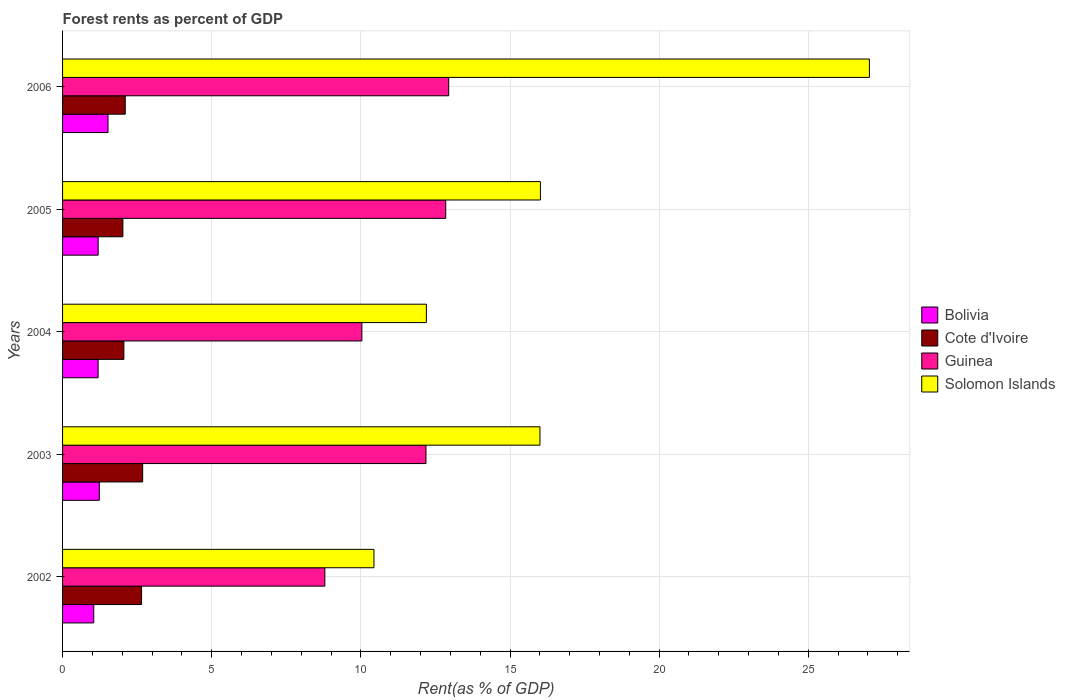How many different coloured bars are there?
Your answer should be very brief. 4. Are the number of bars per tick equal to the number of legend labels?
Ensure brevity in your answer.  Yes. Are the number of bars on each tick of the Y-axis equal?
Offer a very short reply. Yes. In how many cases, is the number of bars for a given year not equal to the number of legend labels?
Offer a terse response. 0. What is the forest rent in Bolivia in 2003?
Offer a terse response. 1.23. Across all years, what is the maximum forest rent in Bolivia?
Ensure brevity in your answer.  1.52. Across all years, what is the minimum forest rent in Cote d'Ivoire?
Your answer should be compact. 2.02. In which year was the forest rent in Solomon Islands maximum?
Give a very brief answer. 2006. What is the total forest rent in Bolivia in the graph?
Make the answer very short. 6.19. What is the difference between the forest rent in Bolivia in 2002 and that in 2005?
Ensure brevity in your answer.  -0.15. What is the difference between the forest rent in Solomon Islands in 2006 and the forest rent in Cote d'Ivoire in 2005?
Your response must be concise. 25.03. What is the average forest rent in Cote d'Ivoire per year?
Offer a very short reply. 2.3. In the year 2005, what is the difference between the forest rent in Cote d'Ivoire and forest rent in Bolivia?
Your response must be concise. 0.83. In how many years, is the forest rent in Cote d'Ivoire greater than 3 %?
Ensure brevity in your answer.  0. What is the ratio of the forest rent in Bolivia in 2003 to that in 2005?
Your response must be concise. 1.03. Is the difference between the forest rent in Cote d'Ivoire in 2002 and 2005 greater than the difference between the forest rent in Bolivia in 2002 and 2005?
Your response must be concise. Yes. What is the difference between the highest and the second highest forest rent in Bolivia?
Keep it short and to the point. 0.29. What is the difference between the highest and the lowest forest rent in Cote d'Ivoire?
Your answer should be compact. 0.66. In how many years, is the forest rent in Cote d'Ivoire greater than the average forest rent in Cote d'Ivoire taken over all years?
Your answer should be compact. 2. Is it the case that in every year, the sum of the forest rent in Cote d'Ivoire and forest rent in Guinea is greater than the sum of forest rent in Bolivia and forest rent in Solomon Islands?
Offer a very short reply. Yes. What does the 2nd bar from the top in 2005 represents?
Provide a succinct answer. Guinea. What does the 3rd bar from the bottom in 2005 represents?
Give a very brief answer. Guinea. Are all the bars in the graph horizontal?
Make the answer very short. Yes. How many years are there in the graph?
Offer a terse response. 5. What is the difference between two consecutive major ticks on the X-axis?
Keep it short and to the point. 5. Does the graph contain any zero values?
Make the answer very short. No. Where does the legend appear in the graph?
Give a very brief answer. Center right. How many legend labels are there?
Keep it short and to the point. 4. How are the legend labels stacked?
Offer a very short reply. Vertical. What is the title of the graph?
Offer a very short reply. Forest rents as percent of GDP. Does "Mauritius" appear as one of the legend labels in the graph?
Your answer should be very brief. No. What is the label or title of the X-axis?
Offer a terse response. Rent(as % of GDP). What is the Rent(as % of GDP) in Bolivia in 2002?
Your response must be concise. 1.05. What is the Rent(as % of GDP) of Cote d'Ivoire in 2002?
Offer a terse response. 2.65. What is the Rent(as % of GDP) in Guinea in 2002?
Your answer should be very brief. 8.79. What is the Rent(as % of GDP) in Solomon Islands in 2002?
Provide a succinct answer. 10.44. What is the Rent(as % of GDP) of Bolivia in 2003?
Provide a short and direct response. 1.23. What is the Rent(as % of GDP) of Cote d'Ivoire in 2003?
Your response must be concise. 2.69. What is the Rent(as % of GDP) of Guinea in 2003?
Provide a succinct answer. 12.18. What is the Rent(as % of GDP) in Solomon Islands in 2003?
Your answer should be compact. 16. What is the Rent(as % of GDP) in Bolivia in 2004?
Your answer should be very brief. 1.19. What is the Rent(as % of GDP) of Cote d'Ivoire in 2004?
Your answer should be very brief. 2.06. What is the Rent(as % of GDP) in Guinea in 2004?
Your response must be concise. 10.03. What is the Rent(as % of GDP) in Solomon Islands in 2004?
Offer a terse response. 12.2. What is the Rent(as % of GDP) of Bolivia in 2005?
Provide a short and direct response. 1.19. What is the Rent(as % of GDP) of Cote d'Ivoire in 2005?
Your response must be concise. 2.02. What is the Rent(as % of GDP) in Guinea in 2005?
Offer a terse response. 12.85. What is the Rent(as % of GDP) in Solomon Islands in 2005?
Your answer should be compact. 16.02. What is the Rent(as % of GDP) in Bolivia in 2006?
Your response must be concise. 1.52. What is the Rent(as % of GDP) in Cote d'Ivoire in 2006?
Your response must be concise. 2.1. What is the Rent(as % of GDP) in Guinea in 2006?
Offer a very short reply. 12.95. What is the Rent(as % of GDP) of Solomon Islands in 2006?
Your answer should be compact. 27.05. Across all years, what is the maximum Rent(as % of GDP) in Bolivia?
Give a very brief answer. 1.52. Across all years, what is the maximum Rent(as % of GDP) in Cote d'Ivoire?
Provide a succinct answer. 2.69. Across all years, what is the maximum Rent(as % of GDP) of Guinea?
Provide a short and direct response. 12.95. Across all years, what is the maximum Rent(as % of GDP) of Solomon Islands?
Your answer should be compact. 27.05. Across all years, what is the minimum Rent(as % of GDP) in Bolivia?
Your response must be concise. 1.05. Across all years, what is the minimum Rent(as % of GDP) in Cote d'Ivoire?
Make the answer very short. 2.02. Across all years, what is the minimum Rent(as % of GDP) in Guinea?
Provide a short and direct response. 8.79. Across all years, what is the minimum Rent(as % of GDP) in Solomon Islands?
Ensure brevity in your answer.  10.44. What is the total Rent(as % of GDP) of Bolivia in the graph?
Keep it short and to the point. 6.19. What is the total Rent(as % of GDP) in Cote d'Ivoire in the graph?
Make the answer very short. 11.51. What is the total Rent(as % of GDP) in Guinea in the graph?
Provide a short and direct response. 56.8. What is the total Rent(as % of GDP) of Solomon Islands in the graph?
Provide a succinct answer. 81.71. What is the difference between the Rent(as % of GDP) in Bolivia in 2002 and that in 2003?
Your answer should be compact. -0.19. What is the difference between the Rent(as % of GDP) of Cote d'Ivoire in 2002 and that in 2003?
Offer a very short reply. -0.04. What is the difference between the Rent(as % of GDP) of Guinea in 2002 and that in 2003?
Your response must be concise. -3.39. What is the difference between the Rent(as % of GDP) in Solomon Islands in 2002 and that in 2003?
Your response must be concise. -5.56. What is the difference between the Rent(as % of GDP) of Bolivia in 2002 and that in 2004?
Give a very brief answer. -0.15. What is the difference between the Rent(as % of GDP) of Cote d'Ivoire in 2002 and that in 2004?
Your answer should be very brief. 0.59. What is the difference between the Rent(as % of GDP) in Guinea in 2002 and that in 2004?
Offer a very short reply. -1.24. What is the difference between the Rent(as % of GDP) in Solomon Islands in 2002 and that in 2004?
Your answer should be compact. -1.76. What is the difference between the Rent(as % of GDP) of Bolivia in 2002 and that in 2005?
Your answer should be compact. -0.15. What is the difference between the Rent(as % of GDP) in Cote d'Ivoire in 2002 and that in 2005?
Provide a short and direct response. 0.63. What is the difference between the Rent(as % of GDP) of Guinea in 2002 and that in 2005?
Offer a terse response. -4.05. What is the difference between the Rent(as % of GDP) of Solomon Islands in 2002 and that in 2005?
Your answer should be compact. -5.58. What is the difference between the Rent(as % of GDP) in Bolivia in 2002 and that in 2006?
Your answer should be very brief. -0.48. What is the difference between the Rent(as % of GDP) in Cote d'Ivoire in 2002 and that in 2006?
Provide a succinct answer. 0.55. What is the difference between the Rent(as % of GDP) of Guinea in 2002 and that in 2006?
Keep it short and to the point. -4.15. What is the difference between the Rent(as % of GDP) of Solomon Islands in 2002 and that in 2006?
Your answer should be compact. -16.61. What is the difference between the Rent(as % of GDP) of Bolivia in 2003 and that in 2004?
Provide a succinct answer. 0.04. What is the difference between the Rent(as % of GDP) in Cote d'Ivoire in 2003 and that in 2004?
Your response must be concise. 0.63. What is the difference between the Rent(as % of GDP) of Guinea in 2003 and that in 2004?
Your answer should be very brief. 2.15. What is the difference between the Rent(as % of GDP) of Solomon Islands in 2003 and that in 2004?
Your answer should be very brief. 3.81. What is the difference between the Rent(as % of GDP) in Bolivia in 2003 and that in 2005?
Your response must be concise. 0.04. What is the difference between the Rent(as % of GDP) of Cote d'Ivoire in 2003 and that in 2005?
Offer a terse response. 0.66. What is the difference between the Rent(as % of GDP) in Guinea in 2003 and that in 2005?
Offer a terse response. -0.66. What is the difference between the Rent(as % of GDP) of Solomon Islands in 2003 and that in 2005?
Provide a short and direct response. -0.02. What is the difference between the Rent(as % of GDP) in Bolivia in 2003 and that in 2006?
Make the answer very short. -0.29. What is the difference between the Rent(as % of GDP) of Cote d'Ivoire in 2003 and that in 2006?
Give a very brief answer. 0.58. What is the difference between the Rent(as % of GDP) in Guinea in 2003 and that in 2006?
Give a very brief answer. -0.76. What is the difference between the Rent(as % of GDP) of Solomon Islands in 2003 and that in 2006?
Offer a terse response. -11.04. What is the difference between the Rent(as % of GDP) in Bolivia in 2004 and that in 2005?
Provide a short and direct response. -0. What is the difference between the Rent(as % of GDP) in Cote d'Ivoire in 2004 and that in 2005?
Offer a terse response. 0.03. What is the difference between the Rent(as % of GDP) in Guinea in 2004 and that in 2005?
Your answer should be compact. -2.81. What is the difference between the Rent(as % of GDP) of Solomon Islands in 2004 and that in 2005?
Your response must be concise. -3.82. What is the difference between the Rent(as % of GDP) of Bolivia in 2004 and that in 2006?
Give a very brief answer. -0.33. What is the difference between the Rent(as % of GDP) of Cote d'Ivoire in 2004 and that in 2006?
Offer a very short reply. -0.05. What is the difference between the Rent(as % of GDP) in Guinea in 2004 and that in 2006?
Your answer should be compact. -2.91. What is the difference between the Rent(as % of GDP) in Solomon Islands in 2004 and that in 2006?
Ensure brevity in your answer.  -14.85. What is the difference between the Rent(as % of GDP) of Bolivia in 2005 and that in 2006?
Your answer should be very brief. -0.33. What is the difference between the Rent(as % of GDP) of Cote d'Ivoire in 2005 and that in 2006?
Keep it short and to the point. -0.08. What is the difference between the Rent(as % of GDP) of Solomon Islands in 2005 and that in 2006?
Offer a terse response. -11.03. What is the difference between the Rent(as % of GDP) in Bolivia in 2002 and the Rent(as % of GDP) in Cote d'Ivoire in 2003?
Provide a succinct answer. -1.64. What is the difference between the Rent(as % of GDP) of Bolivia in 2002 and the Rent(as % of GDP) of Guinea in 2003?
Provide a succinct answer. -11.14. What is the difference between the Rent(as % of GDP) of Bolivia in 2002 and the Rent(as % of GDP) of Solomon Islands in 2003?
Your response must be concise. -14.96. What is the difference between the Rent(as % of GDP) in Cote d'Ivoire in 2002 and the Rent(as % of GDP) in Guinea in 2003?
Keep it short and to the point. -9.53. What is the difference between the Rent(as % of GDP) of Cote d'Ivoire in 2002 and the Rent(as % of GDP) of Solomon Islands in 2003?
Your response must be concise. -13.36. What is the difference between the Rent(as % of GDP) in Guinea in 2002 and the Rent(as % of GDP) in Solomon Islands in 2003?
Provide a succinct answer. -7.21. What is the difference between the Rent(as % of GDP) in Bolivia in 2002 and the Rent(as % of GDP) in Cote d'Ivoire in 2004?
Provide a succinct answer. -1.01. What is the difference between the Rent(as % of GDP) of Bolivia in 2002 and the Rent(as % of GDP) of Guinea in 2004?
Your response must be concise. -8.99. What is the difference between the Rent(as % of GDP) in Bolivia in 2002 and the Rent(as % of GDP) in Solomon Islands in 2004?
Your answer should be compact. -11.15. What is the difference between the Rent(as % of GDP) of Cote d'Ivoire in 2002 and the Rent(as % of GDP) of Guinea in 2004?
Offer a terse response. -7.39. What is the difference between the Rent(as % of GDP) in Cote d'Ivoire in 2002 and the Rent(as % of GDP) in Solomon Islands in 2004?
Ensure brevity in your answer.  -9.55. What is the difference between the Rent(as % of GDP) in Guinea in 2002 and the Rent(as % of GDP) in Solomon Islands in 2004?
Provide a succinct answer. -3.4. What is the difference between the Rent(as % of GDP) of Bolivia in 2002 and the Rent(as % of GDP) of Cote d'Ivoire in 2005?
Your answer should be compact. -0.98. What is the difference between the Rent(as % of GDP) in Bolivia in 2002 and the Rent(as % of GDP) in Guinea in 2005?
Offer a very short reply. -11.8. What is the difference between the Rent(as % of GDP) in Bolivia in 2002 and the Rent(as % of GDP) in Solomon Islands in 2005?
Your response must be concise. -14.97. What is the difference between the Rent(as % of GDP) in Cote d'Ivoire in 2002 and the Rent(as % of GDP) in Guinea in 2005?
Ensure brevity in your answer.  -10.2. What is the difference between the Rent(as % of GDP) of Cote d'Ivoire in 2002 and the Rent(as % of GDP) of Solomon Islands in 2005?
Give a very brief answer. -13.37. What is the difference between the Rent(as % of GDP) of Guinea in 2002 and the Rent(as % of GDP) of Solomon Islands in 2005?
Provide a succinct answer. -7.23. What is the difference between the Rent(as % of GDP) of Bolivia in 2002 and the Rent(as % of GDP) of Cote d'Ivoire in 2006?
Keep it short and to the point. -1.06. What is the difference between the Rent(as % of GDP) in Bolivia in 2002 and the Rent(as % of GDP) in Guinea in 2006?
Your answer should be compact. -11.9. What is the difference between the Rent(as % of GDP) in Bolivia in 2002 and the Rent(as % of GDP) in Solomon Islands in 2006?
Offer a terse response. -26. What is the difference between the Rent(as % of GDP) in Cote d'Ivoire in 2002 and the Rent(as % of GDP) in Guinea in 2006?
Offer a very short reply. -10.3. What is the difference between the Rent(as % of GDP) of Cote d'Ivoire in 2002 and the Rent(as % of GDP) of Solomon Islands in 2006?
Offer a very short reply. -24.4. What is the difference between the Rent(as % of GDP) in Guinea in 2002 and the Rent(as % of GDP) in Solomon Islands in 2006?
Your answer should be very brief. -18.26. What is the difference between the Rent(as % of GDP) in Bolivia in 2003 and the Rent(as % of GDP) in Cote d'Ivoire in 2004?
Offer a very short reply. -0.82. What is the difference between the Rent(as % of GDP) of Bolivia in 2003 and the Rent(as % of GDP) of Guinea in 2004?
Your answer should be very brief. -8.8. What is the difference between the Rent(as % of GDP) of Bolivia in 2003 and the Rent(as % of GDP) of Solomon Islands in 2004?
Provide a short and direct response. -10.97. What is the difference between the Rent(as % of GDP) of Cote d'Ivoire in 2003 and the Rent(as % of GDP) of Guinea in 2004?
Provide a short and direct response. -7.35. What is the difference between the Rent(as % of GDP) in Cote d'Ivoire in 2003 and the Rent(as % of GDP) in Solomon Islands in 2004?
Offer a terse response. -9.51. What is the difference between the Rent(as % of GDP) in Guinea in 2003 and the Rent(as % of GDP) in Solomon Islands in 2004?
Ensure brevity in your answer.  -0.01. What is the difference between the Rent(as % of GDP) in Bolivia in 2003 and the Rent(as % of GDP) in Cote d'Ivoire in 2005?
Make the answer very short. -0.79. What is the difference between the Rent(as % of GDP) of Bolivia in 2003 and the Rent(as % of GDP) of Guinea in 2005?
Your response must be concise. -11.61. What is the difference between the Rent(as % of GDP) of Bolivia in 2003 and the Rent(as % of GDP) of Solomon Islands in 2005?
Your answer should be very brief. -14.79. What is the difference between the Rent(as % of GDP) in Cote d'Ivoire in 2003 and the Rent(as % of GDP) in Guinea in 2005?
Ensure brevity in your answer.  -10.16. What is the difference between the Rent(as % of GDP) of Cote d'Ivoire in 2003 and the Rent(as % of GDP) of Solomon Islands in 2005?
Offer a very short reply. -13.33. What is the difference between the Rent(as % of GDP) in Guinea in 2003 and the Rent(as % of GDP) in Solomon Islands in 2005?
Your answer should be very brief. -3.84. What is the difference between the Rent(as % of GDP) of Bolivia in 2003 and the Rent(as % of GDP) of Cote d'Ivoire in 2006?
Offer a very short reply. -0.87. What is the difference between the Rent(as % of GDP) in Bolivia in 2003 and the Rent(as % of GDP) in Guinea in 2006?
Provide a succinct answer. -11.71. What is the difference between the Rent(as % of GDP) of Bolivia in 2003 and the Rent(as % of GDP) of Solomon Islands in 2006?
Ensure brevity in your answer.  -25.82. What is the difference between the Rent(as % of GDP) in Cote d'Ivoire in 2003 and the Rent(as % of GDP) in Guinea in 2006?
Give a very brief answer. -10.26. What is the difference between the Rent(as % of GDP) in Cote d'Ivoire in 2003 and the Rent(as % of GDP) in Solomon Islands in 2006?
Provide a short and direct response. -24.36. What is the difference between the Rent(as % of GDP) in Guinea in 2003 and the Rent(as % of GDP) in Solomon Islands in 2006?
Provide a short and direct response. -14.87. What is the difference between the Rent(as % of GDP) in Bolivia in 2004 and the Rent(as % of GDP) in Cote d'Ivoire in 2005?
Make the answer very short. -0.83. What is the difference between the Rent(as % of GDP) of Bolivia in 2004 and the Rent(as % of GDP) of Guinea in 2005?
Keep it short and to the point. -11.65. What is the difference between the Rent(as % of GDP) of Bolivia in 2004 and the Rent(as % of GDP) of Solomon Islands in 2005?
Provide a succinct answer. -14.83. What is the difference between the Rent(as % of GDP) of Cote d'Ivoire in 2004 and the Rent(as % of GDP) of Guinea in 2005?
Ensure brevity in your answer.  -10.79. What is the difference between the Rent(as % of GDP) in Cote d'Ivoire in 2004 and the Rent(as % of GDP) in Solomon Islands in 2005?
Ensure brevity in your answer.  -13.96. What is the difference between the Rent(as % of GDP) in Guinea in 2004 and the Rent(as % of GDP) in Solomon Islands in 2005?
Offer a very short reply. -5.99. What is the difference between the Rent(as % of GDP) in Bolivia in 2004 and the Rent(as % of GDP) in Cote d'Ivoire in 2006?
Provide a succinct answer. -0.91. What is the difference between the Rent(as % of GDP) of Bolivia in 2004 and the Rent(as % of GDP) of Guinea in 2006?
Provide a succinct answer. -11.75. What is the difference between the Rent(as % of GDP) in Bolivia in 2004 and the Rent(as % of GDP) in Solomon Islands in 2006?
Give a very brief answer. -25.86. What is the difference between the Rent(as % of GDP) of Cote d'Ivoire in 2004 and the Rent(as % of GDP) of Guinea in 2006?
Offer a very short reply. -10.89. What is the difference between the Rent(as % of GDP) of Cote d'Ivoire in 2004 and the Rent(as % of GDP) of Solomon Islands in 2006?
Ensure brevity in your answer.  -24.99. What is the difference between the Rent(as % of GDP) in Guinea in 2004 and the Rent(as % of GDP) in Solomon Islands in 2006?
Offer a very short reply. -17.01. What is the difference between the Rent(as % of GDP) in Bolivia in 2005 and the Rent(as % of GDP) in Cote d'Ivoire in 2006?
Your response must be concise. -0.91. What is the difference between the Rent(as % of GDP) of Bolivia in 2005 and the Rent(as % of GDP) of Guinea in 2006?
Your response must be concise. -11.75. What is the difference between the Rent(as % of GDP) of Bolivia in 2005 and the Rent(as % of GDP) of Solomon Islands in 2006?
Provide a short and direct response. -25.86. What is the difference between the Rent(as % of GDP) of Cote d'Ivoire in 2005 and the Rent(as % of GDP) of Guinea in 2006?
Offer a very short reply. -10.92. What is the difference between the Rent(as % of GDP) of Cote d'Ivoire in 2005 and the Rent(as % of GDP) of Solomon Islands in 2006?
Offer a very short reply. -25.03. What is the difference between the Rent(as % of GDP) in Guinea in 2005 and the Rent(as % of GDP) in Solomon Islands in 2006?
Provide a short and direct response. -14.2. What is the average Rent(as % of GDP) of Bolivia per year?
Your answer should be compact. 1.24. What is the average Rent(as % of GDP) of Cote d'Ivoire per year?
Your answer should be very brief. 2.3. What is the average Rent(as % of GDP) in Guinea per year?
Offer a very short reply. 11.36. What is the average Rent(as % of GDP) in Solomon Islands per year?
Provide a short and direct response. 16.34. In the year 2002, what is the difference between the Rent(as % of GDP) in Bolivia and Rent(as % of GDP) in Cote d'Ivoire?
Your response must be concise. -1.6. In the year 2002, what is the difference between the Rent(as % of GDP) in Bolivia and Rent(as % of GDP) in Guinea?
Your answer should be compact. -7.75. In the year 2002, what is the difference between the Rent(as % of GDP) of Bolivia and Rent(as % of GDP) of Solomon Islands?
Make the answer very short. -9.39. In the year 2002, what is the difference between the Rent(as % of GDP) of Cote d'Ivoire and Rent(as % of GDP) of Guinea?
Give a very brief answer. -6.14. In the year 2002, what is the difference between the Rent(as % of GDP) in Cote d'Ivoire and Rent(as % of GDP) in Solomon Islands?
Your response must be concise. -7.79. In the year 2002, what is the difference between the Rent(as % of GDP) of Guinea and Rent(as % of GDP) of Solomon Islands?
Make the answer very short. -1.65. In the year 2003, what is the difference between the Rent(as % of GDP) of Bolivia and Rent(as % of GDP) of Cote d'Ivoire?
Offer a very short reply. -1.45. In the year 2003, what is the difference between the Rent(as % of GDP) in Bolivia and Rent(as % of GDP) in Guinea?
Your answer should be very brief. -10.95. In the year 2003, what is the difference between the Rent(as % of GDP) of Bolivia and Rent(as % of GDP) of Solomon Islands?
Offer a very short reply. -14.77. In the year 2003, what is the difference between the Rent(as % of GDP) of Cote d'Ivoire and Rent(as % of GDP) of Guinea?
Keep it short and to the point. -9.5. In the year 2003, what is the difference between the Rent(as % of GDP) of Cote d'Ivoire and Rent(as % of GDP) of Solomon Islands?
Make the answer very short. -13.32. In the year 2003, what is the difference between the Rent(as % of GDP) of Guinea and Rent(as % of GDP) of Solomon Islands?
Your response must be concise. -3.82. In the year 2004, what is the difference between the Rent(as % of GDP) in Bolivia and Rent(as % of GDP) in Cote d'Ivoire?
Keep it short and to the point. -0.86. In the year 2004, what is the difference between the Rent(as % of GDP) of Bolivia and Rent(as % of GDP) of Guinea?
Keep it short and to the point. -8.84. In the year 2004, what is the difference between the Rent(as % of GDP) in Bolivia and Rent(as % of GDP) in Solomon Islands?
Offer a terse response. -11.01. In the year 2004, what is the difference between the Rent(as % of GDP) in Cote d'Ivoire and Rent(as % of GDP) in Guinea?
Your answer should be compact. -7.98. In the year 2004, what is the difference between the Rent(as % of GDP) of Cote d'Ivoire and Rent(as % of GDP) of Solomon Islands?
Offer a very short reply. -10.14. In the year 2004, what is the difference between the Rent(as % of GDP) in Guinea and Rent(as % of GDP) in Solomon Islands?
Provide a succinct answer. -2.16. In the year 2005, what is the difference between the Rent(as % of GDP) of Bolivia and Rent(as % of GDP) of Cote d'Ivoire?
Give a very brief answer. -0.83. In the year 2005, what is the difference between the Rent(as % of GDP) of Bolivia and Rent(as % of GDP) of Guinea?
Provide a short and direct response. -11.65. In the year 2005, what is the difference between the Rent(as % of GDP) in Bolivia and Rent(as % of GDP) in Solomon Islands?
Provide a succinct answer. -14.83. In the year 2005, what is the difference between the Rent(as % of GDP) of Cote d'Ivoire and Rent(as % of GDP) of Guinea?
Provide a short and direct response. -10.82. In the year 2005, what is the difference between the Rent(as % of GDP) of Cote d'Ivoire and Rent(as % of GDP) of Solomon Islands?
Offer a very short reply. -14. In the year 2005, what is the difference between the Rent(as % of GDP) in Guinea and Rent(as % of GDP) in Solomon Islands?
Provide a short and direct response. -3.17. In the year 2006, what is the difference between the Rent(as % of GDP) in Bolivia and Rent(as % of GDP) in Cote d'Ivoire?
Your answer should be very brief. -0.58. In the year 2006, what is the difference between the Rent(as % of GDP) in Bolivia and Rent(as % of GDP) in Guinea?
Make the answer very short. -11.42. In the year 2006, what is the difference between the Rent(as % of GDP) of Bolivia and Rent(as % of GDP) of Solomon Islands?
Offer a terse response. -25.52. In the year 2006, what is the difference between the Rent(as % of GDP) of Cote d'Ivoire and Rent(as % of GDP) of Guinea?
Your answer should be very brief. -10.84. In the year 2006, what is the difference between the Rent(as % of GDP) in Cote d'Ivoire and Rent(as % of GDP) in Solomon Islands?
Ensure brevity in your answer.  -24.95. In the year 2006, what is the difference between the Rent(as % of GDP) in Guinea and Rent(as % of GDP) in Solomon Islands?
Give a very brief answer. -14.1. What is the ratio of the Rent(as % of GDP) of Bolivia in 2002 to that in 2003?
Give a very brief answer. 0.85. What is the ratio of the Rent(as % of GDP) of Cote d'Ivoire in 2002 to that in 2003?
Your response must be concise. 0.99. What is the ratio of the Rent(as % of GDP) in Guinea in 2002 to that in 2003?
Ensure brevity in your answer.  0.72. What is the ratio of the Rent(as % of GDP) in Solomon Islands in 2002 to that in 2003?
Provide a succinct answer. 0.65. What is the ratio of the Rent(as % of GDP) of Bolivia in 2002 to that in 2004?
Keep it short and to the point. 0.88. What is the ratio of the Rent(as % of GDP) in Cote d'Ivoire in 2002 to that in 2004?
Provide a succinct answer. 1.29. What is the ratio of the Rent(as % of GDP) of Guinea in 2002 to that in 2004?
Your response must be concise. 0.88. What is the ratio of the Rent(as % of GDP) of Solomon Islands in 2002 to that in 2004?
Provide a succinct answer. 0.86. What is the ratio of the Rent(as % of GDP) of Bolivia in 2002 to that in 2005?
Ensure brevity in your answer.  0.88. What is the ratio of the Rent(as % of GDP) of Cote d'Ivoire in 2002 to that in 2005?
Give a very brief answer. 1.31. What is the ratio of the Rent(as % of GDP) of Guinea in 2002 to that in 2005?
Your answer should be compact. 0.68. What is the ratio of the Rent(as % of GDP) in Solomon Islands in 2002 to that in 2005?
Your answer should be compact. 0.65. What is the ratio of the Rent(as % of GDP) in Bolivia in 2002 to that in 2006?
Keep it short and to the point. 0.69. What is the ratio of the Rent(as % of GDP) of Cote d'Ivoire in 2002 to that in 2006?
Make the answer very short. 1.26. What is the ratio of the Rent(as % of GDP) in Guinea in 2002 to that in 2006?
Your answer should be compact. 0.68. What is the ratio of the Rent(as % of GDP) in Solomon Islands in 2002 to that in 2006?
Offer a very short reply. 0.39. What is the ratio of the Rent(as % of GDP) in Bolivia in 2003 to that in 2004?
Your answer should be compact. 1.03. What is the ratio of the Rent(as % of GDP) of Cote d'Ivoire in 2003 to that in 2004?
Provide a short and direct response. 1.31. What is the ratio of the Rent(as % of GDP) in Guinea in 2003 to that in 2004?
Provide a succinct answer. 1.21. What is the ratio of the Rent(as % of GDP) of Solomon Islands in 2003 to that in 2004?
Your answer should be very brief. 1.31. What is the ratio of the Rent(as % of GDP) in Bolivia in 2003 to that in 2005?
Your response must be concise. 1.03. What is the ratio of the Rent(as % of GDP) in Cote d'Ivoire in 2003 to that in 2005?
Keep it short and to the point. 1.33. What is the ratio of the Rent(as % of GDP) in Guinea in 2003 to that in 2005?
Offer a very short reply. 0.95. What is the ratio of the Rent(as % of GDP) of Solomon Islands in 2003 to that in 2005?
Offer a terse response. 1. What is the ratio of the Rent(as % of GDP) of Bolivia in 2003 to that in 2006?
Your response must be concise. 0.81. What is the ratio of the Rent(as % of GDP) in Cote d'Ivoire in 2003 to that in 2006?
Ensure brevity in your answer.  1.28. What is the ratio of the Rent(as % of GDP) in Guinea in 2003 to that in 2006?
Make the answer very short. 0.94. What is the ratio of the Rent(as % of GDP) in Solomon Islands in 2003 to that in 2006?
Your response must be concise. 0.59. What is the ratio of the Rent(as % of GDP) of Cote d'Ivoire in 2004 to that in 2005?
Ensure brevity in your answer.  1.02. What is the ratio of the Rent(as % of GDP) in Guinea in 2004 to that in 2005?
Make the answer very short. 0.78. What is the ratio of the Rent(as % of GDP) of Solomon Islands in 2004 to that in 2005?
Provide a succinct answer. 0.76. What is the ratio of the Rent(as % of GDP) in Bolivia in 2004 to that in 2006?
Provide a short and direct response. 0.78. What is the ratio of the Rent(as % of GDP) of Cote d'Ivoire in 2004 to that in 2006?
Give a very brief answer. 0.98. What is the ratio of the Rent(as % of GDP) of Guinea in 2004 to that in 2006?
Provide a succinct answer. 0.78. What is the ratio of the Rent(as % of GDP) of Solomon Islands in 2004 to that in 2006?
Make the answer very short. 0.45. What is the ratio of the Rent(as % of GDP) of Bolivia in 2005 to that in 2006?
Give a very brief answer. 0.78. What is the ratio of the Rent(as % of GDP) of Cote d'Ivoire in 2005 to that in 2006?
Keep it short and to the point. 0.96. What is the ratio of the Rent(as % of GDP) of Solomon Islands in 2005 to that in 2006?
Your response must be concise. 0.59. What is the difference between the highest and the second highest Rent(as % of GDP) of Bolivia?
Keep it short and to the point. 0.29. What is the difference between the highest and the second highest Rent(as % of GDP) of Cote d'Ivoire?
Offer a terse response. 0.04. What is the difference between the highest and the second highest Rent(as % of GDP) in Solomon Islands?
Provide a succinct answer. 11.03. What is the difference between the highest and the lowest Rent(as % of GDP) of Bolivia?
Provide a short and direct response. 0.48. What is the difference between the highest and the lowest Rent(as % of GDP) of Cote d'Ivoire?
Offer a very short reply. 0.66. What is the difference between the highest and the lowest Rent(as % of GDP) in Guinea?
Offer a very short reply. 4.15. What is the difference between the highest and the lowest Rent(as % of GDP) in Solomon Islands?
Provide a succinct answer. 16.61. 